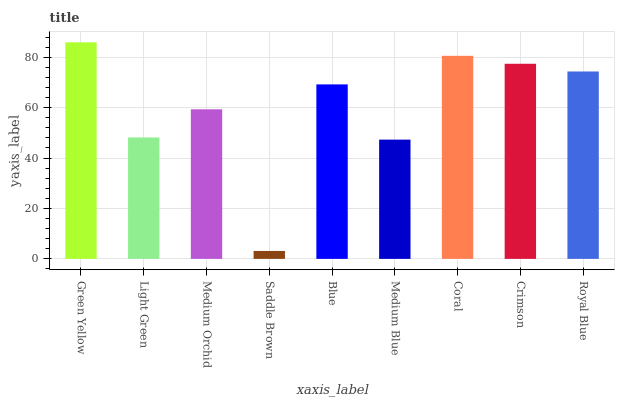Is Saddle Brown the minimum?
Answer yes or no. Yes. Is Green Yellow the maximum?
Answer yes or no. Yes. Is Light Green the minimum?
Answer yes or no. No. Is Light Green the maximum?
Answer yes or no. No. Is Green Yellow greater than Light Green?
Answer yes or no. Yes. Is Light Green less than Green Yellow?
Answer yes or no. Yes. Is Light Green greater than Green Yellow?
Answer yes or no. No. Is Green Yellow less than Light Green?
Answer yes or no. No. Is Blue the high median?
Answer yes or no. Yes. Is Blue the low median?
Answer yes or no. Yes. Is Green Yellow the high median?
Answer yes or no. No. Is Royal Blue the low median?
Answer yes or no. No. 